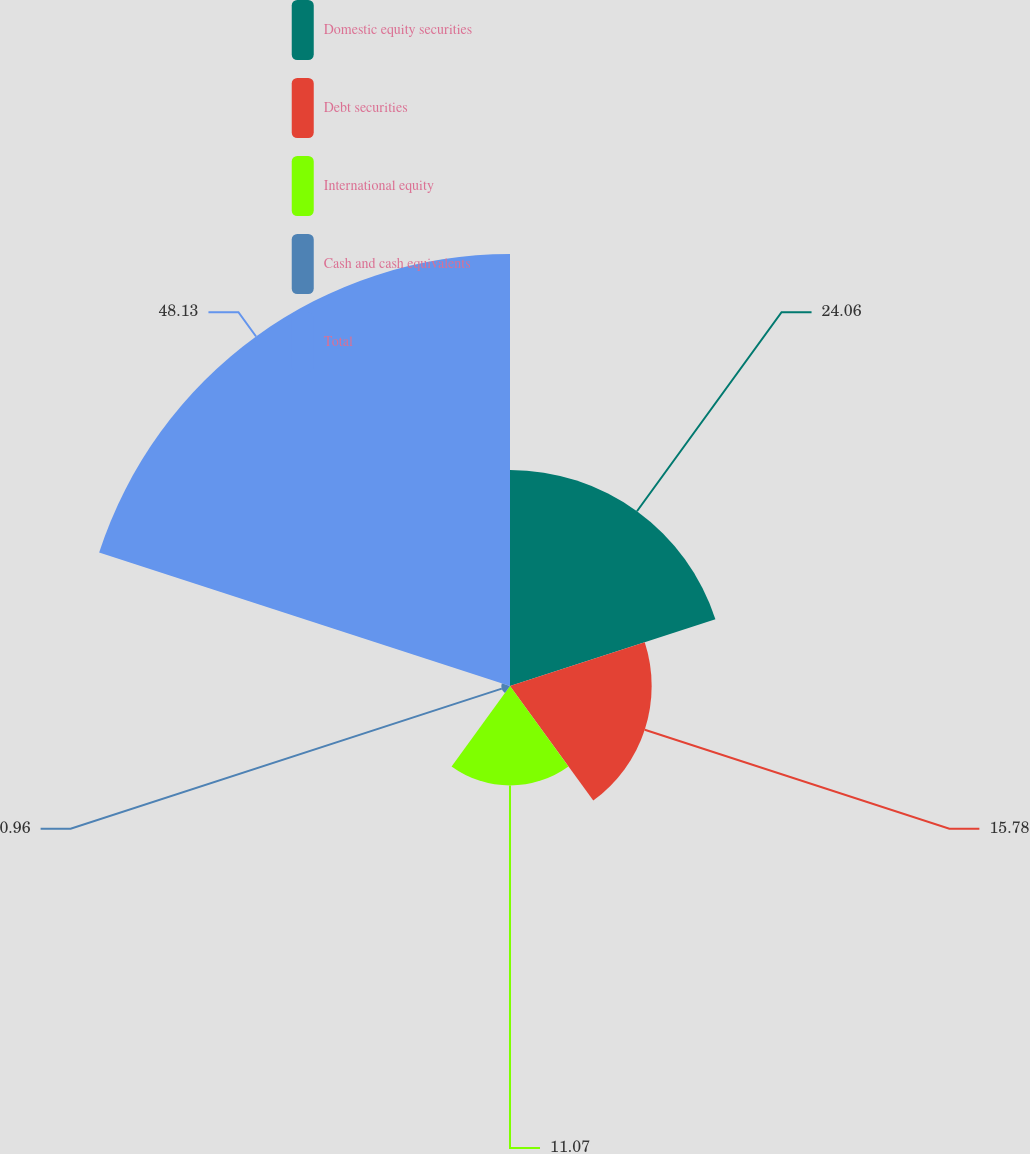Convert chart to OTSL. <chart><loc_0><loc_0><loc_500><loc_500><pie_chart><fcel>Domestic equity securities<fcel>Debt securities<fcel>International equity<fcel>Cash and cash equivalents<fcel>Total<nl><fcel>24.06%<fcel>15.78%<fcel>11.07%<fcel>0.96%<fcel>48.12%<nl></chart> 